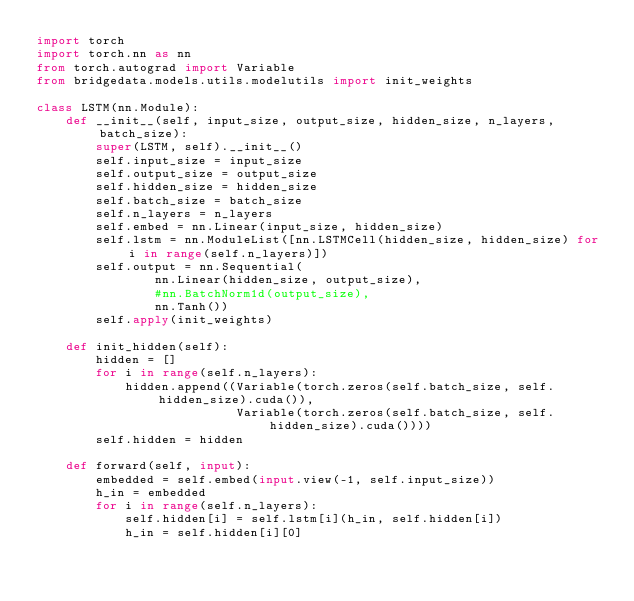Convert code to text. <code><loc_0><loc_0><loc_500><loc_500><_Python_>import torch
import torch.nn as nn
from torch.autograd import Variable
from bridgedata.models.utils.modelutils import init_weights

class LSTM(nn.Module):
    def __init__(self, input_size, output_size, hidden_size, n_layers, batch_size):
        super(LSTM, self).__init__()
        self.input_size = input_size
        self.output_size = output_size
        self.hidden_size = hidden_size
        self.batch_size = batch_size
        self.n_layers = n_layers
        self.embed = nn.Linear(input_size, hidden_size)
        self.lstm = nn.ModuleList([nn.LSTMCell(hidden_size, hidden_size) for i in range(self.n_layers)])
        self.output = nn.Sequential(
                nn.Linear(hidden_size, output_size),
                #nn.BatchNorm1d(output_size),
                nn.Tanh())
        self.apply(init_weights)

    def init_hidden(self):
        hidden = []
        for i in range(self.n_layers):
            hidden.append((Variable(torch.zeros(self.batch_size, self.hidden_size).cuda()),
                           Variable(torch.zeros(self.batch_size, self.hidden_size).cuda())))
        self.hidden = hidden

    def forward(self, input):
        embedded = self.embed(input.view(-1, self.input_size))
        h_in = embedded
        for i in range(self.n_layers):
            self.hidden[i] = self.lstm[i](h_in, self.hidden[i])
            h_in = self.hidden[i][0]
</code> 